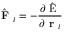<formula> <loc_0><loc_0><loc_500><loc_500>\hat { F } _ { i } = - \frac { \partial \hat { E } } { \partial r _ { i } }</formula> 